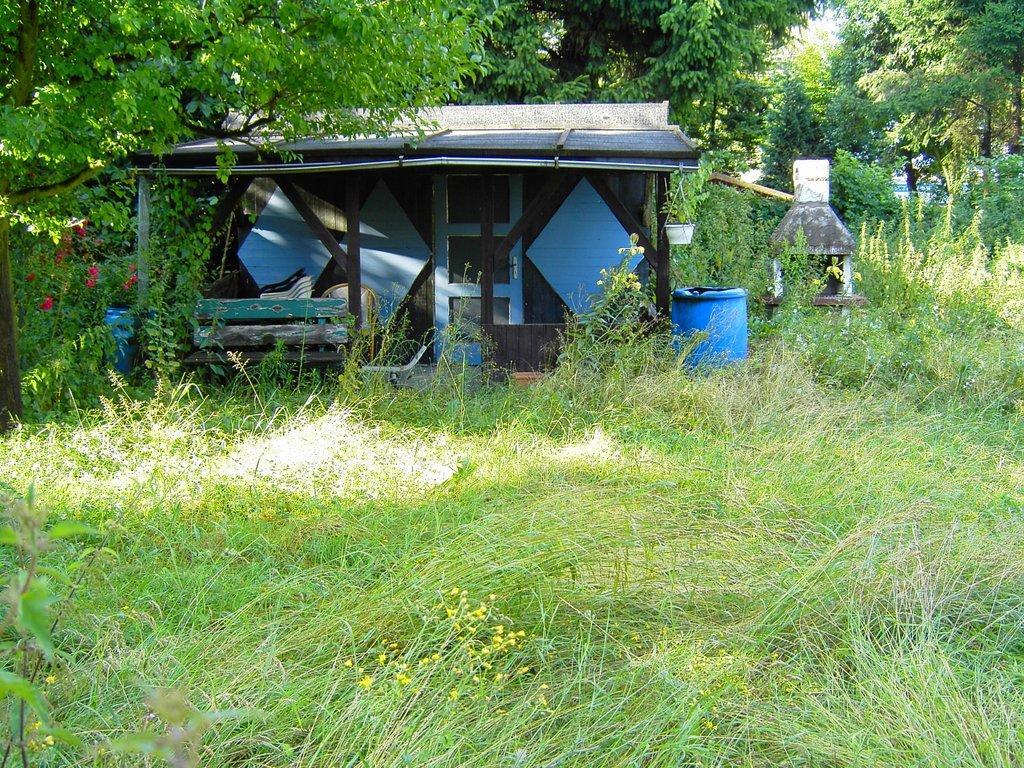Could you give a brief overview of what you see in this image? In this image there are trees towards the top of the image, there are plants towards the bottom of the image, there are flowers, there is a wooden house, there is a door, there are chairs, there are objects on the ground. 